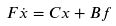Convert formula to latex. <formula><loc_0><loc_0><loc_500><loc_500>F \dot { x } = C x + B f</formula> 